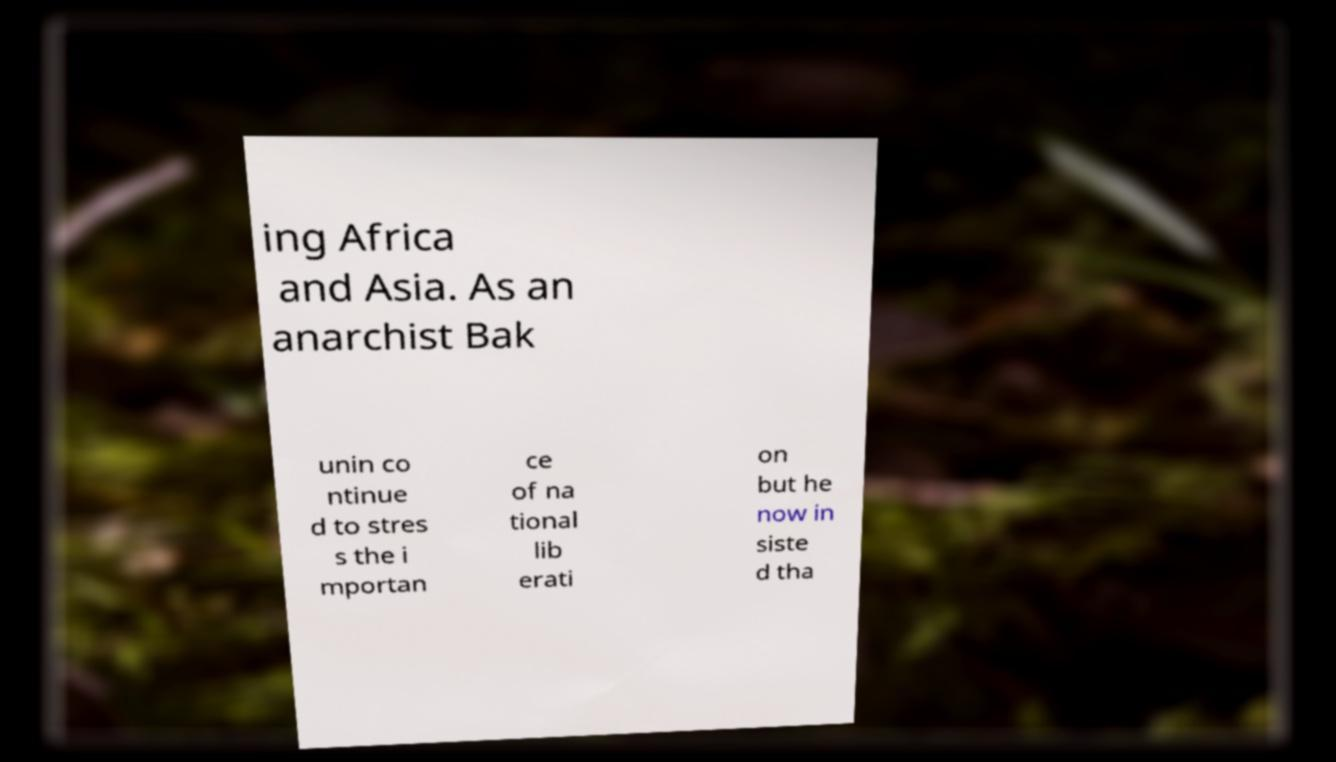Can you read and provide the text displayed in the image?This photo seems to have some interesting text. Can you extract and type it out for me? ing Africa and Asia. As an anarchist Bak unin co ntinue d to stres s the i mportan ce of na tional lib erati on but he now in siste d tha 